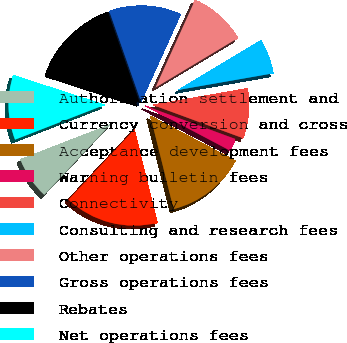Convert chart. <chart><loc_0><loc_0><loc_500><loc_500><pie_chart><fcel>Authorization settlement and<fcel>Currency conversion and cross<fcel>Acceptance development fees<fcel>Warning bulletin fees<fcel>Connectivity<fcel>Consulting and research fees<fcel>Other operations fees<fcel>Gross operations fees<fcel>Rebates<fcel>Net operations fees<nl><fcel>7.11%<fcel>15.89%<fcel>13.38%<fcel>2.11%<fcel>8.37%<fcel>5.86%<fcel>9.62%<fcel>12.13%<fcel>14.64%<fcel>10.88%<nl></chart> 